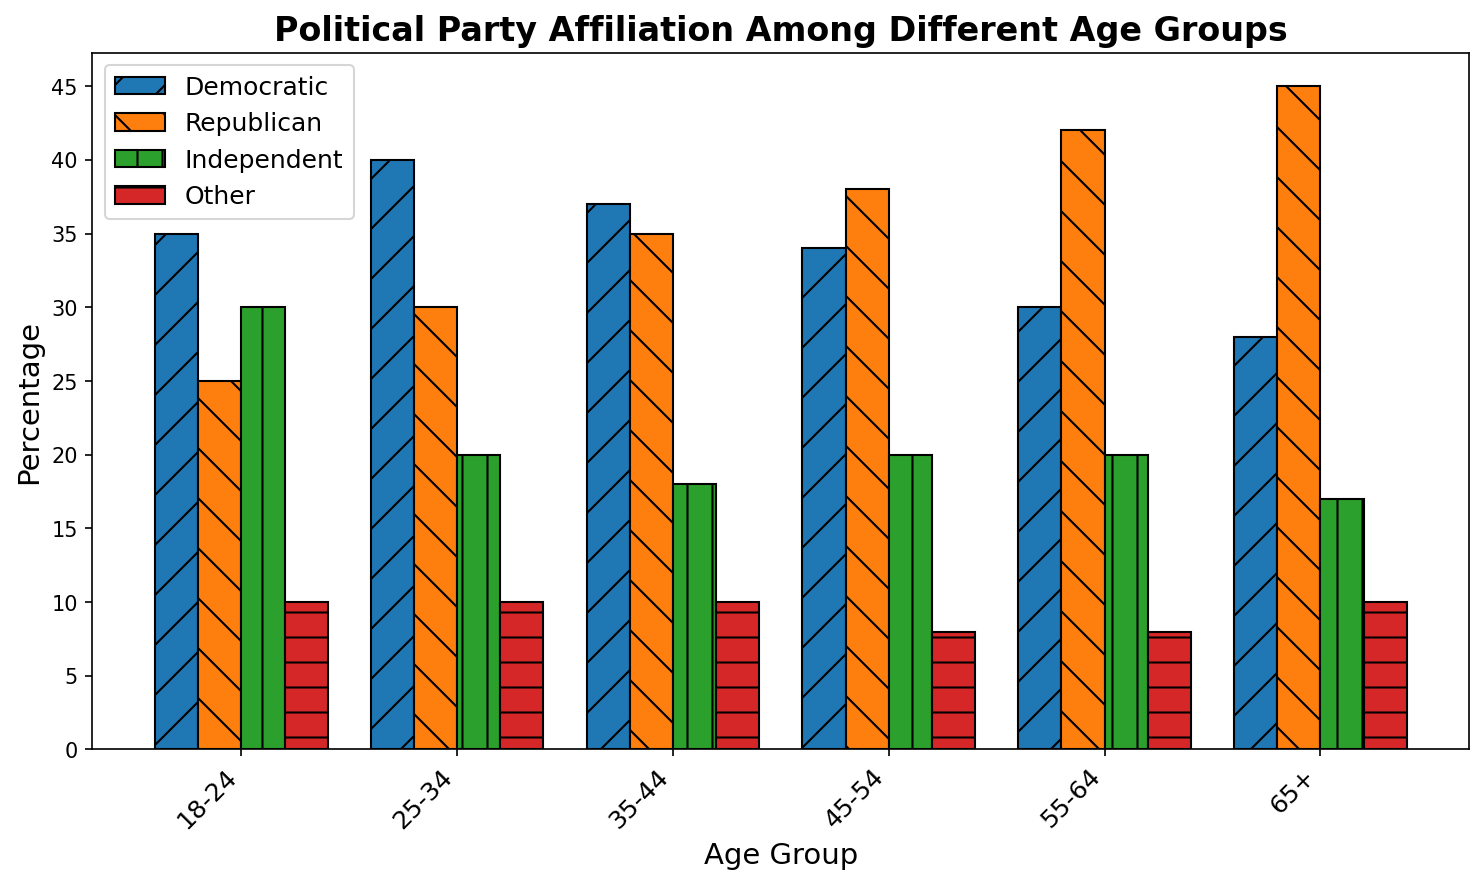What's the percentage of the Independent affiliation in the 18-24 age group? By looking at the bar colored in green for the "Independent" category within the "18-24" age group, we see the height of the bar represents 30%.
Answer: 30% Which age group has the highest percentage of Republican affiliation? The orange bars represent the Republican affiliation. By comparing the heights of these bars across different age groups, the "65+" age group has the highest at 45%.
Answer: 65+ What is the total percentage of Democratic affiliation across all age groups? Sum the Democratic percentages across all age groups: 35 (18-24) + 40 (25-34) + 37 (35-44) + 34 (45-54) + 30 (55-64) + 28 (65+) = 204.
Answer: 204% Among the Independent affiliation, which age group shows the least percentage? The green bars represent the Independent affiliation. By comparing the heights of these bars, the "65+" age group shows the least at 17%.
Answer: 65+ Calculate the average percentage of Republican affiliation for individuals aged 35 and above (35-44, 45-54, 55-64, 65+). Add the Republican percentages for each relevant age group (35-44, 45-54, 55-64, 65+) and then divide by the number of groups: (35 + 38 + 42 + 45) / 4 = 160 / 4 = 40.
Answer: 40% Is the Democratic affiliation more prevalent than the Republican affiliation among the 25-34 age group? Compare the blue bar (Democratic) and the orange bar (Republican) for the "25-34" age group: Democratic is 40%, and Republican is 30%. Since 40% > 30%, the Democratic affiliation is more prevalent.
Answer: Yes Compare the combined percentage of Democratic and Republican affiliations between the 18-24 and 65+ age groups. For the 18-24 age group: Democratic (35%) + Republican (25%) = 60%. For the 65+ age group: Democratic (28%) + Republican (45%) = 73%. Comparing these totals, 60% < 73%.
Answer: 65+ Which age group shows an equal percentage for any two affiliations? Inspect each age group's bars, looking for equal heights. For the "25-34" age group, the "Other" and "Independent" affiliations both have a percentage of 10%.
Answer: 25-34 In the age group 35-44, calculate the difference in percentage points between Democratic and Republican affiliations. Look at the Democratic and Republican bars for 35-44. Democratic is 37%, and Republican is 35%. The difference is 37 - 35 = 2 percentage points.
Answer: 2 Identify the age group with the highest overall percentage (summing all affiliations). Sum all party percentages for each age group: 18-24 (35+25+30+10=100), 25-34 (40+30+20+10=100), 35-44 (37+35+18+10=100), 45-54 (34+38+20+8=100), 55-64 (30+42+20+8=100), 65+ (28+45+17+10=100). All age groups sum to 100%. All age groups have the highest overall percentage because they all total 100%.
Answer: All age groups 